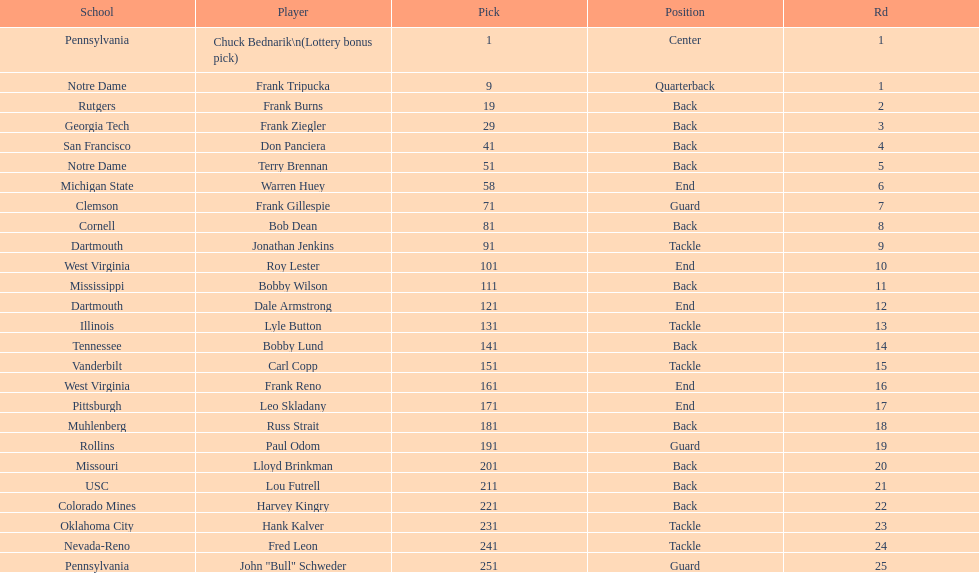Who was picked after frank burns? Frank Ziegler. 